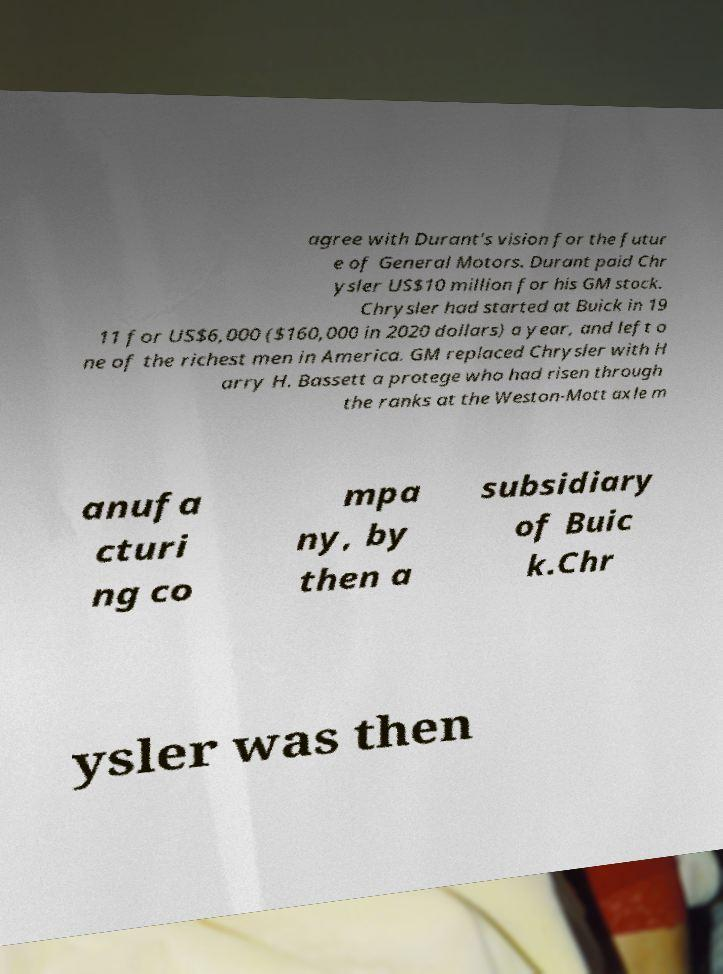Please read and relay the text visible in this image. What does it say? agree with Durant's vision for the futur e of General Motors. Durant paid Chr ysler US$10 million for his GM stock. Chrysler had started at Buick in 19 11 for US$6,000 ($160,000 in 2020 dollars) a year, and left o ne of the richest men in America. GM replaced Chrysler with H arry H. Bassett a protege who had risen through the ranks at the Weston-Mott axle m anufa cturi ng co mpa ny, by then a subsidiary of Buic k.Chr ysler was then 